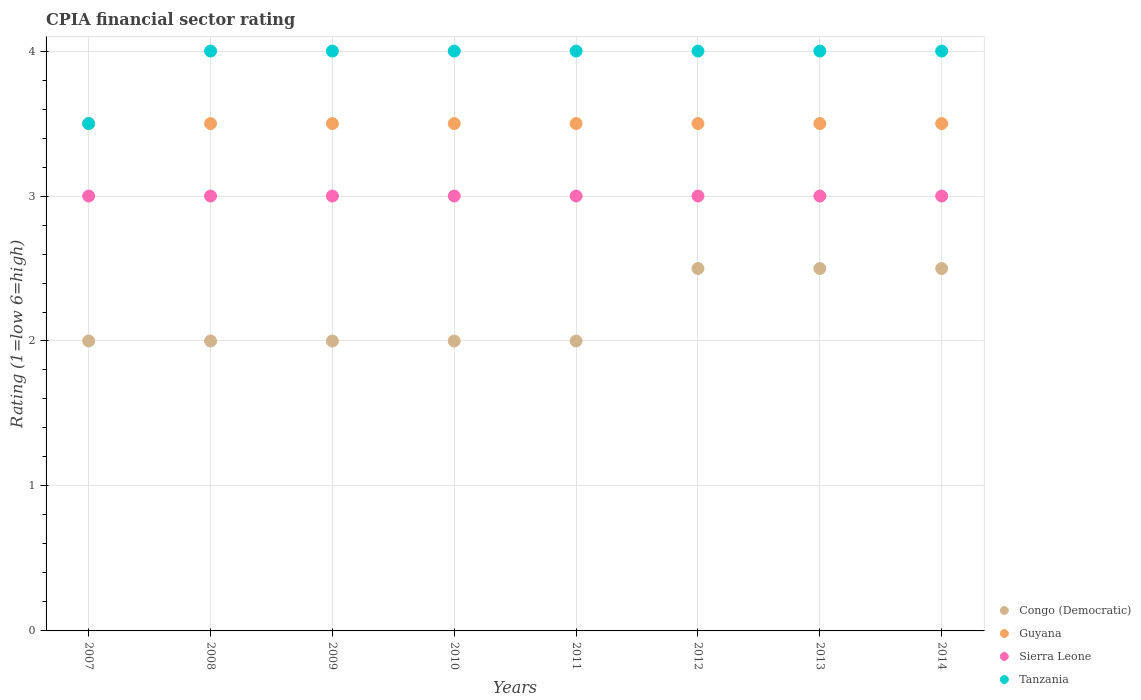How many different coloured dotlines are there?
Your answer should be very brief. 4. Is the number of dotlines equal to the number of legend labels?
Make the answer very short. Yes. What is the CPIA rating in Sierra Leone in 2012?
Ensure brevity in your answer.  3. Across all years, what is the maximum CPIA rating in Sierra Leone?
Your answer should be compact. 3. Across all years, what is the minimum CPIA rating in Sierra Leone?
Keep it short and to the point. 3. In which year was the CPIA rating in Guyana maximum?
Provide a short and direct response. 2007. What is the total CPIA rating in Guyana in the graph?
Provide a short and direct response. 28. What is the difference between the CPIA rating in Congo (Democratic) in 2008 and the CPIA rating in Guyana in 2009?
Offer a terse response. -1.5. What is the ratio of the CPIA rating in Congo (Democratic) in 2007 to that in 2012?
Keep it short and to the point. 0.8. Is the CPIA rating in Congo (Democratic) in 2009 less than that in 2010?
Give a very brief answer. No. What is the difference between the highest and the second highest CPIA rating in Guyana?
Provide a succinct answer. 0. What is the difference between the highest and the lowest CPIA rating in Tanzania?
Offer a terse response. 0.5. Is it the case that in every year, the sum of the CPIA rating in Tanzania and CPIA rating in Guyana  is greater than the sum of CPIA rating in Sierra Leone and CPIA rating in Congo (Democratic)?
Ensure brevity in your answer.  No. Is it the case that in every year, the sum of the CPIA rating in Congo (Democratic) and CPIA rating in Guyana  is greater than the CPIA rating in Tanzania?
Give a very brief answer. Yes. Is the CPIA rating in Sierra Leone strictly greater than the CPIA rating in Congo (Democratic) over the years?
Your answer should be compact. Yes. How many years are there in the graph?
Your answer should be compact. 8. Are the values on the major ticks of Y-axis written in scientific E-notation?
Make the answer very short. No. Where does the legend appear in the graph?
Your answer should be very brief. Bottom right. How many legend labels are there?
Keep it short and to the point. 4. How are the legend labels stacked?
Provide a succinct answer. Vertical. What is the title of the graph?
Provide a short and direct response. CPIA financial sector rating. What is the label or title of the X-axis?
Provide a short and direct response. Years. What is the label or title of the Y-axis?
Your answer should be very brief. Rating (1=low 6=high). What is the Rating (1=low 6=high) of Tanzania in 2007?
Provide a succinct answer. 3.5. What is the Rating (1=low 6=high) in Congo (Democratic) in 2008?
Offer a terse response. 2. What is the Rating (1=low 6=high) of Tanzania in 2008?
Ensure brevity in your answer.  4. What is the Rating (1=low 6=high) in Tanzania in 2009?
Provide a succinct answer. 4. What is the Rating (1=low 6=high) of Congo (Democratic) in 2010?
Provide a succinct answer. 2. What is the Rating (1=low 6=high) of Sierra Leone in 2010?
Provide a short and direct response. 3. What is the Rating (1=low 6=high) in Tanzania in 2010?
Your response must be concise. 4. What is the Rating (1=low 6=high) in Guyana in 2011?
Your response must be concise. 3.5. What is the Rating (1=low 6=high) of Sierra Leone in 2011?
Your answer should be compact. 3. What is the Rating (1=low 6=high) of Guyana in 2012?
Your answer should be compact. 3.5. What is the Rating (1=low 6=high) in Tanzania in 2012?
Your answer should be compact. 4. What is the Rating (1=low 6=high) of Congo (Democratic) in 2013?
Keep it short and to the point. 2.5. What is the Rating (1=low 6=high) of Tanzania in 2013?
Your response must be concise. 4. What is the Rating (1=low 6=high) in Congo (Democratic) in 2014?
Offer a very short reply. 2.5. Across all years, what is the maximum Rating (1=low 6=high) of Congo (Democratic)?
Ensure brevity in your answer.  2.5. Across all years, what is the maximum Rating (1=low 6=high) of Tanzania?
Offer a terse response. 4. Across all years, what is the minimum Rating (1=low 6=high) of Congo (Democratic)?
Provide a succinct answer. 2. What is the total Rating (1=low 6=high) of Congo (Democratic) in the graph?
Your answer should be very brief. 17.5. What is the total Rating (1=low 6=high) of Guyana in the graph?
Ensure brevity in your answer.  28. What is the total Rating (1=low 6=high) in Sierra Leone in the graph?
Your answer should be very brief. 24. What is the total Rating (1=low 6=high) of Tanzania in the graph?
Offer a very short reply. 31.5. What is the difference between the Rating (1=low 6=high) in Sierra Leone in 2007 and that in 2008?
Offer a very short reply. 0. What is the difference between the Rating (1=low 6=high) of Congo (Democratic) in 2007 and that in 2009?
Your answer should be very brief. 0. What is the difference between the Rating (1=low 6=high) of Guyana in 2007 and that in 2009?
Provide a succinct answer. 0. What is the difference between the Rating (1=low 6=high) in Sierra Leone in 2007 and that in 2009?
Your answer should be very brief. 0. What is the difference between the Rating (1=low 6=high) of Tanzania in 2007 and that in 2009?
Ensure brevity in your answer.  -0.5. What is the difference between the Rating (1=low 6=high) in Congo (Democratic) in 2007 and that in 2010?
Ensure brevity in your answer.  0. What is the difference between the Rating (1=low 6=high) of Sierra Leone in 2007 and that in 2010?
Give a very brief answer. 0. What is the difference between the Rating (1=low 6=high) of Tanzania in 2007 and that in 2010?
Offer a terse response. -0.5. What is the difference between the Rating (1=low 6=high) of Guyana in 2007 and that in 2011?
Your response must be concise. 0. What is the difference between the Rating (1=low 6=high) of Sierra Leone in 2007 and that in 2011?
Your answer should be compact. 0. What is the difference between the Rating (1=low 6=high) of Congo (Democratic) in 2007 and that in 2012?
Your answer should be compact. -0.5. What is the difference between the Rating (1=low 6=high) in Guyana in 2007 and that in 2012?
Give a very brief answer. 0. What is the difference between the Rating (1=low 6=high) in Sierra Leone in 2007 and that in 2012?
Ensure brevity in your answer.  0. What is the difference between the Rating (1=low 6=high) in Tanzania in 2007 and that in 2012?
Offer a very short reply. -0.5. What is the difference between the Rating (1=low 6=high) of Congo (Democratic) in 2007 and that in 2013?
Provide a short and direct response. -0.5. What is the difference between the Rating (1=low 6=high) of Guyana in 2007 and that in 2013?
Your answer should be compact. 0. What is the difference between the Rating (1=low 6=high) of Sierra Leone in 2007 and that in 2013?
Make the answer very short. 0. What is the difference between the Rating (1=low 6=high) of Guyana in 2007 and that in 2014?
Keep it short and to the point. 0. What is the difference between the Rating (1=low 6=high) in Sierra Leone in 2007 and that in 2014?
Provide a succinct answer. 0. What is the difference between the Rating (1=low 6=high) in Tanzania in 2007 and that in 2014?
Your answer should be very brief. -0.5. What is the difference between the Rating (1=low 6=high) in Guyana in 2008 and that in 2009?
Your answer should be very brief. 0. What is the difference between the Rating (1=low 6=high) in Sierra Leone in 2008 and that in 2009?
Provide a succinct answer. 0. What is the difference between the Rating (1=low 6=high) in Tanzania in 2008 and that in 2009?
Offer a terse response. 0. What is the difference between the Rating (1=low 6=high) of Guyana in 2008 and that in 2010?
Provide a succinct answer. 0. What is the difference between the Rating (1=low 6=high) of Sierra Leone in 2008 and that in 2010?
Provide a succinct answer. 0. What is the difference between the Rating (1=low 6=high) of Tanzania in 2008 and that in 2010?
Provide a succinct answer. 0. What is the difference between the Rating (1=low 6=high) of Congo (Democratic) in 2008 and that in 2011?
Ensure brevity in your answer.  0. What is the difference between the Rating (1=low 6=high) of Sierra Leone in 2008 and that in 2011?
Your answer should be compact. 0. What is the difference between the Rating (1=low 6=high) of Congo (Democratic) in 2008 and that in 2012?
Make the answer very short. -0.5. What is the difference between the Rating (1=low 6=high) of Guyana in 2008 and that in 2012?
Give a very brief answer. 0. What is the difference between the Rating (1=low 6=high) of Congo (Democratic) in 2008 and that in 2013?
Keep it short and to the point. -0.5. What is the difference between the Rating (1=low 6=high) of Guyana in 2008 and that in 2013?
Provide a succinct answer. 0. What is the difference between the Rating (1=low 6=high) in Guyana in 2009 and that in 2010?
Your response must be concise. 0. What is the difference between the Rating (1=low 6=high) of Congo (Democratic) in 2009 and that in 2011?
Ensure brevity in your answer.  0. What is the difference between the Rating (1=low 6=high) in Guyana in 2009 and that in 2011?
Offer a very short reply. 0. What is the difference between the Rating (1=low 6=high) in Sierra Leone in 2009 and that in 2011?
Your response must be concise. 0. What is the difference between the Rating (1=low 6=high) in Sierra Leone in 2009 and that in 2012?
Provide a succinct answer. 0. What is the difference between the Rating (1=low 6=high) of Congo (Democratic) in 2009 and that in 2013?
Keep it short and to the point. -0.5. What is the difference between the Rating (1=low 6=high) of Guyana in 2009 and that in 2013?
Give a very brief answer. 0. What is the difference between the Rating (1=low 6=high) of Sierra Leone in 2009 and that in 2013?
Offer a terse response. 0. What is the difference between the Rating (1=low 6=high) of Congo (Democratic) in 2009 and that in 2014?
Make the answer very short. -0.5. What is the difference between the Rating (1=low 6=high) in Guyana in 2009 and that in 2014?
Provide a succinct answer. 0. What is the difference between the Rating (1=low 6=high) in Sierra Leone in 2009 and that in 2014?
Make the answer very short. 0. What is the difference between the Rating (1=low 6=high) of Tanzania in 2009 and that in 2014?
Provide a succinct answer. 0. What is the difference between the Rating (1=low 6=high) in Guyana in 2010 and that in 2011?
Your answer should be very brief. 0. What is the difference between the Rating (1=low 6=high) in Tanzania in 2010 and that in 2011?
Your response must be concise. 0. What is the difference between the Rating (1=low 6=high) of Congo (Democratic) in 2010 and that in 2012?
Offer a very short reply. -0.5. What is the difference between the Rating (1=low 6=high) in Sierra Leone in 2010 and that in 2012?
Give a very brief answer. 0. What is the difference between the Rating (1=low 6=high) of Tanzania in 2010 and that in 2012?
Your response must be concise. 0. What is the difference between the Rating (1=low 6=high) in Congo (Democratic) in 2010 and that in 2013?
Keep it short and to the point. -0.5. What is the difference between the Rating (1=low 6=high) in Congo (Democratic) in 2010 and that in 2014?
Your answer should be very brief. -0.5. What is the difference between the Rating (1=low 6=high) in Guyana in 2010 and that in 2014?
Your answer should be very brief. 0. What is the difference between the Rating (1=low 6=high) in Sierra Leone in 2010 and that in 2014?
Your answer should be very brief. 0. What is the difference between the Rating (1=low 6=high) of Congo (Democratic) in 2011 and that in 2012?
Offer a terse response. -0.5. What is the difference between the Rating (1=low 6=high) in Tanzania in 2011 and that in 2012?
Your answer should be compact. 0. What is the difference between the Rating (1=low 6=high) of Congo (Democratic) in 2011 and that in 2013?
Make the answer very short. -0.5. What is the difference between the Rating (1=low 6=high) in Sierra Leone in 2011 and that in 2013?
Your response must be concise. 0. What is the difference between the Rating (1=low 6=high) in Sierra Leone in 2011 and that in 2014?
Ensure brevity in your answer.  0. What is the difference between the Rating (1=low 6=high) of Congo (Democratic) in 2012 and that in 2013?
Keep it short and to the point. 0. What is the difference between the Rating (1=low 6=high) of Guyana in 2012 and that in 2013?
Make the answer very short. 0. What is the difference between the Rating (1=low 6=high) in Guyana in 2013 and that in 2014?
Give a very brief answer. 0. What is the difference between the Rating (1=low 6=high) in Sierra Leone in 2013 and that in 2014?
Your answer should be compact. 0. What is the difference between the Rating (1=low 6=high) of Congo (Democratic) in 2007 and the Rating (1=low 6=high) of Tanzania in 2008?
Provide a short and direct response. -2. What is the difference between the Rating (1=low 6=high) in Guyana in 2007 and the Rating (1=low 6=high) in Sierra Leone in 2008?
Provide a short and direct response. 0.5. What is the difference between the Rating (1=low 6=high) in Guyana in 2007 and the Rating (1=low 6=high) in Tanzania in 2008?
Provide a succinct answer. -0.5. What is the difference between the Rating (1=low 6=high) in Congo (Democratic) in 2007 and the Rating (1=low 6=high) in Guyana in 2009?
Ensure brevity in your answer.  -1.5. What is the difference between the Rating (1=low 6=high) in Congo (Democratic) in 2007 and the Rating (1=low 6=high) in Sierra Leone in 2009?
Your answer should be compact. -1. What is the difference between the Rating (1=low 6=high) in Congo (Democratic) in 2007 and the Rating (1=low 6=high) in Tanzania in 2009?
Keep it short and to the point. -2. What is the difference between the Rating (1=low 6=high) of Guyana in 2007 and the Rating (1=low 6=high) of Tanzania in 2009?
Your answer should be compact. -0.5. What is the difference between the Rating (1=low 6=high) of Sierra Leone in 2007 and the Rating (1=low 6=high) of Tanzania in 2009?
Your answer should be very brief. -1. What is the difference between the Rating (1=low 6=high) of Congo (Democratic) in 2007 and the Rating (1=low 6=high) of Sierra Leone in 2010?
Provide a short and direct response. -1. What is the difference between the Rating (1=low 6=high) in Congo (Democratic) in 2007 and the Rating (1=low 6=high) in Tanzania in 2011?
Ensure brevity in your answer.  -2. What is the difference between the Rating (1=low 6=high) in Guyana in 2007 and the Rating (1=low 6=high) in Sierra Leone in 2011?
Your answer should be very brief. 0.5. What is the difference between the Rating (1=low 6=high) of Guyana in 2007 and the Rating (1=low 6=high) of Tanzania in 2011?
Give a very brief answer. -0.5. What is the difference between the Rating (1=low 6=high) in Guyana in 2007 and the Rating (1=low 6=high) in Sierra Leone in 2012?
Offer a very short reply. 0.5. What is the difference between the Rating (1=low 6=high) of Congo (Democratic) in 2007 and the Rating (1=low 6=high) of Sierra Leone in 2013?
Offer a terse response. -1. What is the difference between the Rating (1=low 6=high) of Guyana in 2007 and the Rating (1=low 6=high) of Sierra Leone in 2013?
Ensure brevity in your answer.  0.5. What is the difference between the Rating (1=low 6=high) of Guyana in 2007 and the Rating (1=low 6=high) of Tanzania in 2013?
Ensure brevity in your answer.  -0.5. What is the difference between the Rating (1=low 6=high) in Guyana in 2007 and the Rating (1=low 6=high) in Sierra Leone in 2014?
Your response must be concise. 0.5. What is the difference between the Rating (1=low 6=high) of Congo (Democratic) in 2008 and the Rating (1=low 6=high) of Guyana in 2009?
Your response must be concise. -1.5. What is the difference between the Rating (1=low 6=high) of Congo (Democratic) in 2008 and the Rating (1=low 6=high) of Sierra Leone in 2010?
Your answer should be very brief. -1. What is the difference between the Rating (1=low 6=high) of Congo (Democratic) in 2008 and the Rating (1=low 6=high) of Tanzania in 2010?
Offer a very short reply. -2. What is the difference between the Rating (1=low 6=high) in Guyana in 2008 and the Rating (1=low 6=high) in Tanzania in 2010?
Give a very brief answer. -0.5. What is the difference between the Rating (1=low 6=high) in Sierra Leone in 2008 and the Rating (1=low 6=high) in Tanzania in 2010?
Give a very brief answer. -1. What is the difference between the Rating (1=low 6=high) in Guyana in 2008 and the Rating (1=low 6=high) in Sierra Leone in 2011?
Make the answer very short. 0.5. What is the difference between the Rating (1=low 6=high) of Sierra Leone in 2008 and the Rating (1=low 6=high) of Tanzania in 2011?
Provide a succinct answer. -1. What is the difference between the Rating (1=low 6=high) of Congo (Democratic) in 2008 and the Rating (1=low 6=high) of Sierra Leone in 2012?
Keep it short and to the point. -1. What is the difference between the Rating (1=low 6=high) of Guyana in 2008 and the Rating (1=low 6=high) of Sierra Leone in 2012?
Provide a succinct answer. 0.5. What is the difference between the Rating (1=low 6=high) in Guyana in 2008 and the Rating (1=low 6=high) in Tanzania in 2012?
Give a very brief answer. -0.5. What is the difference between the Rating (1=low 6=high) of Sierra Leone in 2008 and the Rating (1=low 6=high) of Tanzania in 2012?
Your answer should be very brief. -1. What is the difference between the Rating (1=low 6=high) of Guyana in 2008 and the Rating (1=low 6=high) of Sierra Leone in 2013?
Offer a very short reply. 0.5. What is the difference between the Rating (1=low 6=high) in Guyana in 2008 and the Rating (1=low 6=high) in Tanzania in 2013?
Give a very brief answer. -0.5. What is the difference between the Rating (1=low 6=high) in Congo (Democratic) in 2008 and the Rating (1=low 6=high) in Sierra Leone in 2014?
Provide a short and direct response. -1. What is the difference between the Rating (1=low 6=high) in Congo (Democratic) in 2009 and the Rating (1=low 6=high) in Guyana in 2010?
Your answer should be compact. -1.5. What is the difference between the Rating (1=low 6=high) in Congo (Democratic) in 2009 and the Rating (1=low 6=high) in Sierra Leone in 2010?
Offer a terse response. -1. What is the difference between the Rating (1=low 6=high) of Congo (Democratic) in 2009 and the Rating (1=low 6=high) of Tanzania in 2010?
Your answer should be compact. -2. What is the difference between the Rating (1=low 6=high) in Guyana in 2009 and the Rating (1=low 6=high) in Sierra Leone in 2010?
Provide a succinct answer. 0.5. What is the difference between the Rating (1=low 6=high) of Congo (Democratic) in 2009 and the Rating (1=low 6=high) of Tanzania in 2011?
Your answer should be compact. -2. What is the difference between the Rating (1=low 6=high) in Sierra Leone in 2009 and the Rating (1=low 6=high) in Tanzania in 2011?
Provide a short and direct response. -1. What is the difference between the Rating (1=low 6=high) of Congo (Democratic) in 2009 and the Rating (1=low 6=high) of Guyana in 2012?
Ensure brevity in your answer.  -1.5. What is the difference between the Rating (1=low 6=high) in Congo (Democratic) in 2009 and the Rating (1=low 6=high) in Sierra Leone in 2012?
Make the answer very short. -1. What is the difference between the Rating (1=low 6=high) in Congo (Democratic) in 2009 and the Rating (1=low 6=high) in Tanzania in 2012?
Offer a very short reply. -2. What is the difference between the Rating (1=low 6=high) in Guyana in 2009 and the Rating (1=low 6=high) in Tanzania in 2012?
Your answer should be very brief. -0.5. What is the difference between the Rating (1=low 6=high) of Sierra Leone in 2009 and the Rating (1=low 6=high) of Tanzania in 2012?
Provide a short and direct response. -1. What is the difference between the Rating (1=low 6=high) of Congo (Democratic) in 2009 and the Rating (1=low 6=high) of Guyana in 2013?
Make the answer very short. -1.5. What is the difference between the Rating (1=low 6=high) in Congo (Democratic) in 2009 and the Rating (1=low 6=high) in Sierra Leone in 2013?
Your response must be concise. -1. What is the difference between the Rating (1=low 6=high) in Congo (Democratic) in 2009 and the Rating (1=low 6=high) in Tanzania in 2013?
Provide a succinct answer. -2. What is the difference between the Rating (1=low 6=high) in Guyana in 2009 and the Rating (1=low 6=high) in Sierra Leone in 2013?
Your answer should be very brief. 0.5. What is the difference between the Rating (1=low 6=high) of Sierra Leone in 2009 and the Rating (1=low 6=high) of Tanzania in 2013?
Give a very brief answer. -1. What is the difference between the Rating (1=low 6=high) in Congo (Democratic) in 2009 and the Rating (1=low 6=high) in Guyana in 2014?
Ensure brevity in your answer.  -1.5. What is the difference between the Rating (1=low 6=high) in Guyana in 2009 and the Rating (1=low 6=high) in Sierra Leone in 2014?
Keep it short and to the point. 0.5. What is the difference between the Rating (1=low 6=high) of Congo (Democratic) in 2010 and the Rating (1=low 6=high) of Guyana in 2011?
Offer a very short reply. -1.5. What is the difference between the Rating (1=low 6=high) in Congo (Democratic) in 2010 and the Rating (1=low 6=high) in Sierra Leone in 2011?
Offer a very short reply. -1. What is the difference between the Rating (1=low 6=high) of Congo (Democratic) in 2010 and the Rating (1=low 6=high) of Tanzania in 2011?
Ensure brevity in your answer.  -2. What is the difference between the Rating (1=low 6=high) of Guyana in 2010 and the Rating (1=low 6=high) of Sierra Leone in 2011?
Keep it short and to the point. 0.5. What is the difference between the Rating (1=low 6=high) in Sierra Leone in 2010 and the Rating (1=low 6=high) in Tanzania in 2011?
Make the answer very short. -1. What is the difference between the Rating (1=low 6=high) in Guyana in 2010 and the Rating (1=low 6=high) in Sierra Leone in 2012?
Your answer should be very brief. 0.5. What is the difference between the Rating (1=low 6=high) in Sierra Leone in 2010 and the Rating (1=low 6=high) in Tanzania in 2012?
Offer a very short reply. -1. What is the difference between the Rating (1=low 6=high) in Congo (Democratic) in 2010 and the Rating (1=low 6=high) in Guyana in 2013?
Offer a very short reply. -1.5. What is the difference between the Rating (1=low 6=high) of Congo (Democratic) in 2010 and the Rating (1=low 6=high) of Sierra Leone in 2013?
Your answer should be compact. -1. What is the difference between the Rating (1=low 6=high) of Congo (Democratic) in 2010 and the Rating (1=low 6=high) of Tanzania in 2013?
Give a very brief answer. -2. What is the difference between the Rating (1=low 6=high) in Sierra Leone in 2010 and the Rating (1=low 6=high) in Tanzania in 2013?
Keep it short and to the point. -1. What is the difference between the Rating (1=low 6=high) of Congo (Democratic) in 2010 and the Rating (1=low 6=high) of Guyana in 2014?
Make the answer very short. -1.5. What is the difference between the Rating (1=low 6=high) in Congo (Democratic) in 2010 and the Rating (1=low 6=high) in Tanzania in 2014?
Give a very brief answer. -2. What is the difference between the Rating (1=low 6=high) of Guyana in 2010 and the Rating (1=low 6=high) of Tanzania in 2014?
Provide a succinct answer. -0.5. What is the difference between the Rating (1=low 6=high) of Congo (Democratic) in 2011 and the Rating (1=low 6=high) of Guyana in 2012?
Your answer should be compact. -1.5. What is the difference between the Rating (1=low 6=high) in Congo (Democratic) in 2011 and the Rating (1=low 6=high) in Tanzania in 2012?
Ensure brevity in your answer.  -2. What is the difference between the Rating (1=low 6=high) of Guyana in 2011 and the Rating (1=low 6=high) of Sierra Leone in 2012?
Offer a very short reply. 0.5. What is the difference between the Rating (1=low 6=high) of Guyana in 2011 and the Rating (1=low 6=high) of Tanzania in 2012?
Offer a terse response. -0.5. What is the difference between the Rating (1=low 6=high) in Congo (Democratic) in 2011 and the Rating (1=low 6=high) in Guyana in 2013?
Keep it short and to the point. -1.5. What is the difference between the Rating (1=low 6=high) of Guyana in 2011 and the Rating (1=low 6=high) of Sierra Leone in 2013?
Keep it short and to the point. 0.5. What is the difference between the Rating (1=low 6=high) of Guyana in 2011 and the Rating (1=low 6=high) of Tanzania in 2013?
Ensure brevity in your answer.  -0.5. What is the difference between the Rating (1=low 6=high) of Congo (Democratic) in 2011 and the Rating (1=low 6=high) of Tanzania in 2014?
Ensure brevity in your answer.  -2. What is the difference between the Rating (1=low 6=high) of Guyana in 2011 and the Rating (1=low 6=high) of Sierra Leone in 2014?
Make the answer very short. 0.5. What is the difference between the Rating (1=low 6=high) in Guyana in 2011 and the Rating (1=low 6=high) in Tanzania in 2014?
Keep it short and to the point. -0.5. What is the difference between the Rating (1=low 6=high) in Sierra Leone in 2011 and the Rating (1=low 6=high) in Tanzania in 2014?
Offer a very short reply. -1. What is the difference between the Rating (1=low 6=high) of Guyana in 2012 and the Rating (1=low 6=high) of Sierra Leone in 2013?
Keep it short and to the point. 0.5. What is the difference between the Rating (1=low 6=high) of Congo (Democratic) in 2012 and the Rating (1=low 6=high) of Guyana in 2014?
Your response must be concise. -1. What is the difference between the Rating (1=low 6=high) of Congo (Democratic) in 2012 and the Rating (1=low 6=high) of Sierra Leone in 2014?
Make the answer very short. -0.5. What is the difference between the Rating (1=low 6=high) of Congo (Democratic) in 2012 and the Rating (1=low 6=high) of Tanzania in 2014?
Provide a succinct answer. -1.5. What is the difference between the Rating (1=low 6=high) in Congo (Democratic) in 2013 and the Rating (1=low 6=high) in Guyana in 2014?
Your response must be concise. -1. What is the difference between the Rating (1=low 6=high) of Congo (Democratic) in 2013 and the Rating (1=low 6=high) of Sierra Leone in 2014?
Ensure brevity in your answer.  -0.5. What is the difference between the Rating (1=low 6=high) of Guyana in 2013 and the Rating (1=low 6=high) of Sierra Leone in 2014?
Keep it short and to the point. 0.5. What is the difference between the Rating (1=low 6=high) of Sierra Leone in 2013 and the Rating (1=low 6=high) of Tanzania in 2014?
Your response must be concise. -1. What is the average Rating (1=low 6=high) of Congo (Democratic) per year?
Your answer should be very brief. 2.19. What is the average Rating (1=low 6=high) of Tanzania per year?
Give a very brief answer. 3.94. In the year 2007, what is the difference between the Rating (1=low 6=high) in Congo (Democratic) and Rating (1=low 6=high) in Sierra Leone?
Provide a succinct answer. -1. In the year 2007, what is the difference between the Rating (1=low 6=high) of Guyana and Rating (1=low 6=high) of Sierra Leone?
Keep it short and to the point. 0.5. In the year 2007, what is the difference between the Rating (1=low 6=high) in Guyana and Rating (1=low 6=high) in Tanzania?
Offer a very short reply. 0. In the year 2008, what is the difference between the Rating (1=low 6=high) of Congo (Democratic) and Rating (1=low 6=high) of Guyana?
Give a very brief answer. -1.5. In the year 2008, what is the difference between the Rating (1=low 6=high) in Guyana and Rating (1=low 6=high) in Sierra Leone?
Your answer should be compact. 0.5. In the year 2008, what is the difference between the Rating (1=low 6=high) of Guyana and Rating (1=low 6=high) of Tanzania?
Ensure brevity in your answer.  -0.5. In the year 2008, what is the difference between the Rating (1=low 6=high) in Sierra Leone and Rating (1=low 6=high) in Tanzania?
Give a very brief answer. -1. In the year 2009, what is the difference between the Rating (1=low 6=high) of Congo (Democratic) and Rating (1=low 6=high) of Guyana?
Your response must be concise. -1.5. In the year 2009, what is the difference between the Rating (1=low 6=high) of Congo (Democratic) and Rating (1=low 6=high) of Tanzania?
Offer a very short reply. -2. In the year 2009, what is the difference between the Rating (1=low 6=high) of Guyana and Rating (1=low 6=high) of Tanzania?
Make the answer very short. -0.5. In the year 2009, what is the difference between the Rating (1=low 6=high) in Sierra Leone and Rating (1=low 6=high) in Tanzania?
Make the answer very short. -1. In the year 2010, what is the difference between the Rating (1=low 6=high) of Congo (Democratic) and Rating (1=low 6=high) of Sierra Leone?
Your answer should be very brief. -1. In the year 2010, what is the difference between the Rating (1=low 6=high) of Congo (Democratic) and Rating (1=low 6=high) of Tanzania?
Ensure brevity in your answer.  -2. In the year 2010, what is the difference between the Rating (1=low 6=high) of Guyana and Rating (1=low 6=high) of Sierra Leone?
Your answer should be compact. 0.5. In the year 2010, what is the difference between the Rating (1=low 6=high) of Sierra Leone and Rating (1=low 6=high) of Tanzania?
Make the answer very short. -1. In the year 2011, what is the difference between the Rating (1=low 6=high) of Congo (Democratic) and Rating (1=low 6=high) of Sierra Leone?
Your response must be concise. -1. In the year 2011, what is the difference between the Rating (1=low 6=high) in Sierra Leone and Rating (1=low 6=high) in Tanzania?
Make the answer very short. -1. In the year 2012, what is the difference between the Rating (1=low 6=high) in Congo (Democratic) and Rating (1=low 6=high) in Sierra Leone?
Provide a short and direct response. -0.5. In the year 2012, what is the difference between the Rating (1=low 6=high) of Congo (Democratic) and Rating (1=low 6=high) of Tanzania?
Your answer should be very brief. -1.5. In the year 2012, what is the difference between the Rating (1=low 6=high) in Guyana and Rating (1=low 6=high) in Sierra Leone?
Make the answer very short. 0.5. In the year 2012, what is the difference between the Rating (1=low 6=high) in Guyana and Rating (1=low 6=high) in Tanzania?
Your answer should be compact. -0.5. In the year 2012, what is the difference between the Rating (1=low 6=high) of Sierra Leone and Rating (1=low 6=high) of Tanzania?
Keep it short and to the point. -1. In the year 2013, what is the difference between the Rating (1=low 6=high) of Congo (Democratic) and Rating (1=low 6=high) of Guyana?
Offer a very short reply. -1. In the year 2013, what is the difference between the Rating (1=low 6=high) in Congo (Democratic) and Rating (1=low 6=high) in Sierra Leone?
Make the answer very short. -0.5. In the year 2013, what is the difference between the Rating (1=low 6=high) of Congo (Democratic) and Rating (1=low 6=high) of Tanzania?
Your answer should be very brief. -1.5. In the year 2013, what is the difference between the Rating (1=low 6=high) of Guyana and Rating (1=low 6=high) of Sierra Leone?
Offer a terse response. 0.5. In the year 2013, what is the difference between the Rating (1=low 6=high) of Sierra Leone and Rating (1=low 6=high) of Tanzania?
Keep it short and to the point. -1. In the year 2014, what is the difference between the Rating (1=low 6=high) in Congo (Democratic) and Rating (1=low 6=high) in Guyana?
Offer a very short reply. -1. In the year 2014, what is the difference between the Rating (1=low 6=high) in Congo (Democratic) and Rating (1=low 6=high) in Sierra Leone?
Ensure brevity in your answer.  -0.5. In the year 2014, what is the difference between the Rating (1=low 6=high) of Congo (Democratic) and Rating (1=low 6=high) of Tanzania?
Your answer should be compact. -1.5. In the year 2014, what is the difference between the Rating (1=low 6=high) of Guyana and Rating (1=low 6=high) of Sierra Leone?
Your answer should be compact. 0.5. In the year 2014, what is the difference between the Rating (1=low 6=high) in Guyana and Rating (1=low 6=high) in Tanzania?
Ensure brevity in your answer.  -0.5. What is the ratio of the Rating (1=low 6=high) in Congo (Democratic) in 2007 to that in 2008?
Provide a succinct answer. 1. What is the ratio of the Rating (1=low 6=high) of Guyana in 2007 to that in 2008?
Make the answer very short. 1. What is the ratio of the Rating (1=low 6=high) in Congo (Democratic) in 2007 to that in 2009?
Your answer should be compact. 1. What is the ratio of the Rating (1=low 6=high) of Guyana in 2007 to that in 2009?
Offer a very short reply. 1. What is the ratio of the Rating (1=low 6=high) in Sierra Leone in 2007 to that in 2009?
Ensure brevity in your answer.  1. What is the ratio of the Rating (1=low 6=high) of Congo (Democratic) in 2007 to that in 2010?
Ensure brevity in your answer.  1. What is the ratio of the Rating (1=low 6=high) in Guyana in 2007 to that in 2010?
Ensure brevity in your answer.  1. What is the ratio of the Rating (1=low 6=high) in Tanzania in 2007 to that in 2012?
Offer a terse response. 0.88. What is the ratio of the Rating (1=low 6=high) in Congo (Democratic) in 2007 to that in 2013?
Provide a short and direct response. 0.8. What is the ratio of the Rating (1=low 6=high) of Guyana in 2007 to that in 2013?
Provide a succinct answer. 1. What is the ratio of the Rating (1=low 6=high) of Tanzania in 2007 to that in 2013?
Make the answer very short. 0.88. What is the ratio of the Rating (1=low 6=high) in Guyana in 2007 to that in 2014?
Offer a very short reply. 1. What is the ratio of the Rating (1=low 6=high) in Sierra Leone in 2007 to that in 2014?
Ensure brevity in your answer.  1. What is the ratio of the Rating (1=low 6=high) in Guyana in 2008 to that in 2009?
Ensure brevity in your answer.  1. What is the ratio of the Rating (1=low 6=high) of Sierra Leone in 2008 to that in 2009?
Provide a succinct answer. 1. What is the ratio of the Rating (1=low 6=high) in Congo (Democratic) in 2008 to that in 2010?
Your answer should be very brief. 1. What is the ratio of the Rating (1=low 6=high) in Sierra Leone in 2008 to that in 2011?
Offer a very short reply. 1. What is the ratio of the Rating (1=low 6=high) of Tanzania in 2008 to that in 2011?
Your answer should be very brief. 1. What is the ratio of the Rating (1=low 6=high) in Congo (Democratic) in 2008 to that in 2012?
Your answer should be compact. 0.8. What is the ratio of the Rating (1=low 6=high) of Guyana in 2008 to that in 2012?
Your response must be concise. 1. What is the ratio of the Rating (1=low 6=high) in Sierra Leone in 2008 to that in 2012?
Your answer should be very brief. 1. What is the ratio of the Rating (1=low 6=high) of Guyana in 2008 to that in 2013?
Keep it short and to the point. 1. What is the ratio of the Rating (1=low 6=high) in Sierra Leone in 2008 to that in 2013?
Your answer should be very brief. 1. What is the ratio of the Rating (1=low 6=high) of Congo (Democratic) in 2008 to that in 2014?
Give a very brief answer. 0.8. What is the ratio of the Rating (1=low 6=high) in Tanzania in 2008 to that in 2014?
Your answer should be very brief. 1. What is the ratio of the Rating (1=low 6=high) in Guyana in 2009 to that in 2011?
Your answer should be very brief. 1. What is the ratio of the Rating (1=low 6=high) in Congo (Democratic) in 2009 to that in 2012?
Give a very brief answer. 0.8. What is the ratio of the Rating (1=low 6=high) of Guyana in 2009 to that in 2012?
Your response must be concise. 1. What is the ratio of the Rating (1=low 6=high) in Sierra Leone in 2009 to that in 2012?
Make the answer very short. 1. What is the ratio of the Rating (1=low 6=high) of Tanzania in 2009 to that in 2012?
Offer a terse response. 1. What is the ratio of the Rating (1=low 6=high) in Sierra Leone in 2009 to that in 2013?
Ensure brevity in your answer.  1. What is the ratio of the Rating (1=low 6=high) of Tanzania in 2009 to that in 2013?
Keep it short and to the point. 1. What is the ratio of the Rating (1=low 6=high) in Guyana in 2009 to that in 2014?
Your answer should be very brief. 1. What is the ratio of the Rating (1=low 6=high) in Tanzania in 2010 to that in 2012?
Keep it short and to the point. 1. What is the ratio of the Rating (1=low 6=high) in Congo (Democratic) in 2010 to that in 2013?
Your answer should be very brief. 0.8. What is the ratio of the Rating (1=low 6=high) of Guyana in 2010 to that in 2013?
Provide a succinct answer. 1. What is the ratio of the Rating (1=low 6=high) of Guyana in 2010 to that in 2014?
Your response must be concise. 1. What is the ratio of the Rating (1=low 6=high) of Sierra Leone in 2010 to that in 2014?
Ensure brevity in your answer.  1. What is the ratio of the Rating (1=low 6=high) of Tanzania in 2010 to that in 2014?
Your response must be concise. 1. What is the ratio of the Rating (1=low 6=high) in Guyana in 2011 to that in 2012?
Keep it short and to the point. 1. What is the ratio of the Rating (1=low 6=high) of Guyana in 2011 to that in 2013?
Offer a terse response. 1. What is the ratio of the Rating (1=low 6=high) in Sierra Leone in 2011 to that in 2013?
Give a very brief answer. 1. What is the ratio of the Rating (1=low 6=high) in Guyana in 2011 to that in 2014?
Give a very brief answer. 1. What is the ratio of the Rating (1=low 6=high) in Sierra Leone in 2012 to that in 2013?
Ensure brevity in your answer.  1. What is the ratio of the Rating (1=low 6=high) of Tanzania in 2012 to that in 2013?
Ensure brevity in your answer.  1. What is the ratio of the Rating (1=low 6=high) in Guyana in 2012 to that in 2014?
Make the answer very short. 1. What is the ratio of the Rating (1=low 6=high) of Tanzania in 2012 to that in 2014?
Give a very brief answer. 1. What is the ratio of the Rating (1=low 6=high) in Congo (Democratic) in 2013 to that in 2014?
Provide a short and direct response. 1. What is the ratio of the Rating (1=low 6=high) of Guyana in 2013 to that in 2014?
Provide a succinct answer. 1. What is the ratio of the Rating (1=low 6=high) of Sierra Leone in 2013 to that in 2014?
Make the answer very short. 1. What is the difference between the highest and the second highest Rating (1=low 6=high) in Congo (Democratic)?
Provide a short and direct response. 0. What is the difference between the highest and the lowest Rating (1=low 6=high) of Congo (Democratic)?
Your response must be concise. 0.5. What is the difference between the highest and the lowest Rating (1=low 6=high) of Guyana?
Give a very brief answer. 0. What is the difference between the highest and the lowest Rating (1=low 6=high) of Tanzania?
Give a very brief answer. 0.5. 